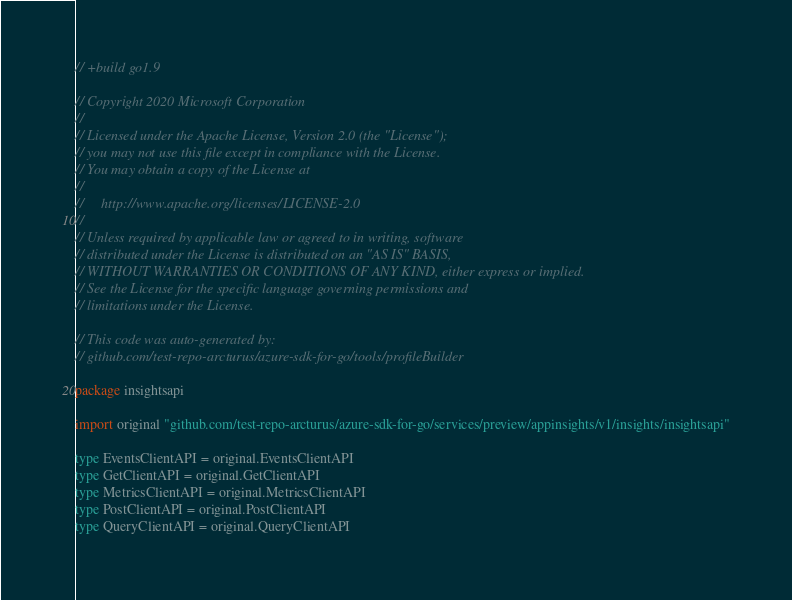Convert code to text. <code><loc_0><loc_0><loc_500><loc_500><_Go_>// +build go1.9

// Copyright 2020 Microsoft Corporation
//
// Licensed under the Apache License, Version 2.0 (the "License");
// you may not use this file except in compliance with the License.
// You may obtain a copy of the License at
//
//     http://www.apache.org/licenses/LICENSE-2.0
//
// Unless required by applicable law or agreed to in writing, software
// distributed under the License is distributed on an "AS IS" BASIS,
// WITHOUT WARRANTIES OR CONDITIONS OF ANY KIND, either express or implied.
// See the License for the specific language governing permissions and
// limitations under the License.

// This code was auto-generated by:
// github.com/test-repo-arcturus/azure-sdk-for-go/tools/profileBuilder

package insightsapi

import original "github.com/test-repo-arcturus/azure-sdk-for-go/services/preview/appinsights/v1/insights/insightsapi"

type EventsClientAPI = original.EventsClientAPI
type GetClientAPI = original.GetClientAPI
type MetricsClientAPI = original.MetricsClientAPI
type PostClientAPI = original.PostClientAPI
type QueryClientAPI = original.QueryClientAPI
</code> 